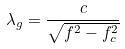Convert formula to latex. <formula><loc_0><loc_0><loc_500><loc_500>\lambda _ { g } = \frac { c } { \sqrt { f ^ { 2 } - f _ { c } ^ { 2 } } }</formula> 